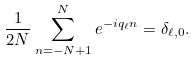Convert formula to latex. <formula><loc_0><loc_0><loc_500><loc_500>\frac { 1 } { 2 N } \sum _ { n = - N + 1 } ^ { N } e ^ { - i q _ { \ell } n } = \delta _ { \ell , 0 } .</formula> 